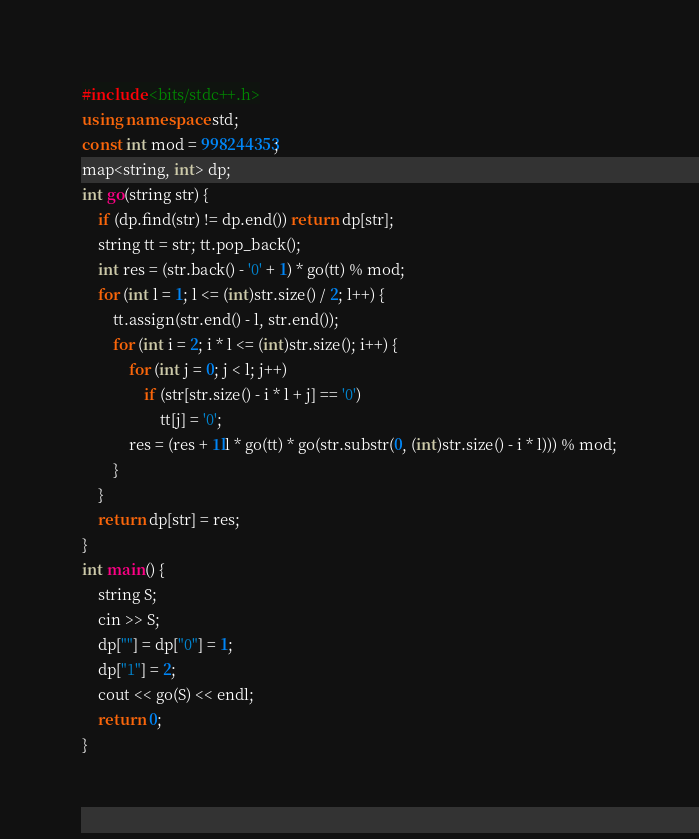Convert code to text. <code><loc_0><loc_0><loc_500><loc_500><_C++_>#include <bits/stdc++.h>
using namespace std;
const int mod = 998244353;
map<string, int> dp;
int go(string str) {
	if (dp.find(str) != dp.end()) return dp[str];
	string tt = str; tt.pop_back();
	int res = (str.back() - '0' + 1) * go(tt) % mod;
	for (int l = 1; l <= (int)str.size() / 2; l++) {
		tt.assign(str.end() - l, str.end());
		for (int i = 2; i * l <= (int)str.size(); i++) {
			for (int j = 0; j < l; j++)
				if (str[str.size() - i * l + j] == '0')
					tt[j] = '0';
			res = (res + 1ll * go(tt) * go(str.substr(0, (int)str.size() - i * l))) % mod;
		}
	}
	return dp[str] = res;
}
int main() {
	string S;
	cin >> S;
	dp[""] = dp["0"] = 1;
	dp["1"] = 2;
	cout << go(S) << endl;
	return 0;
}</code> 